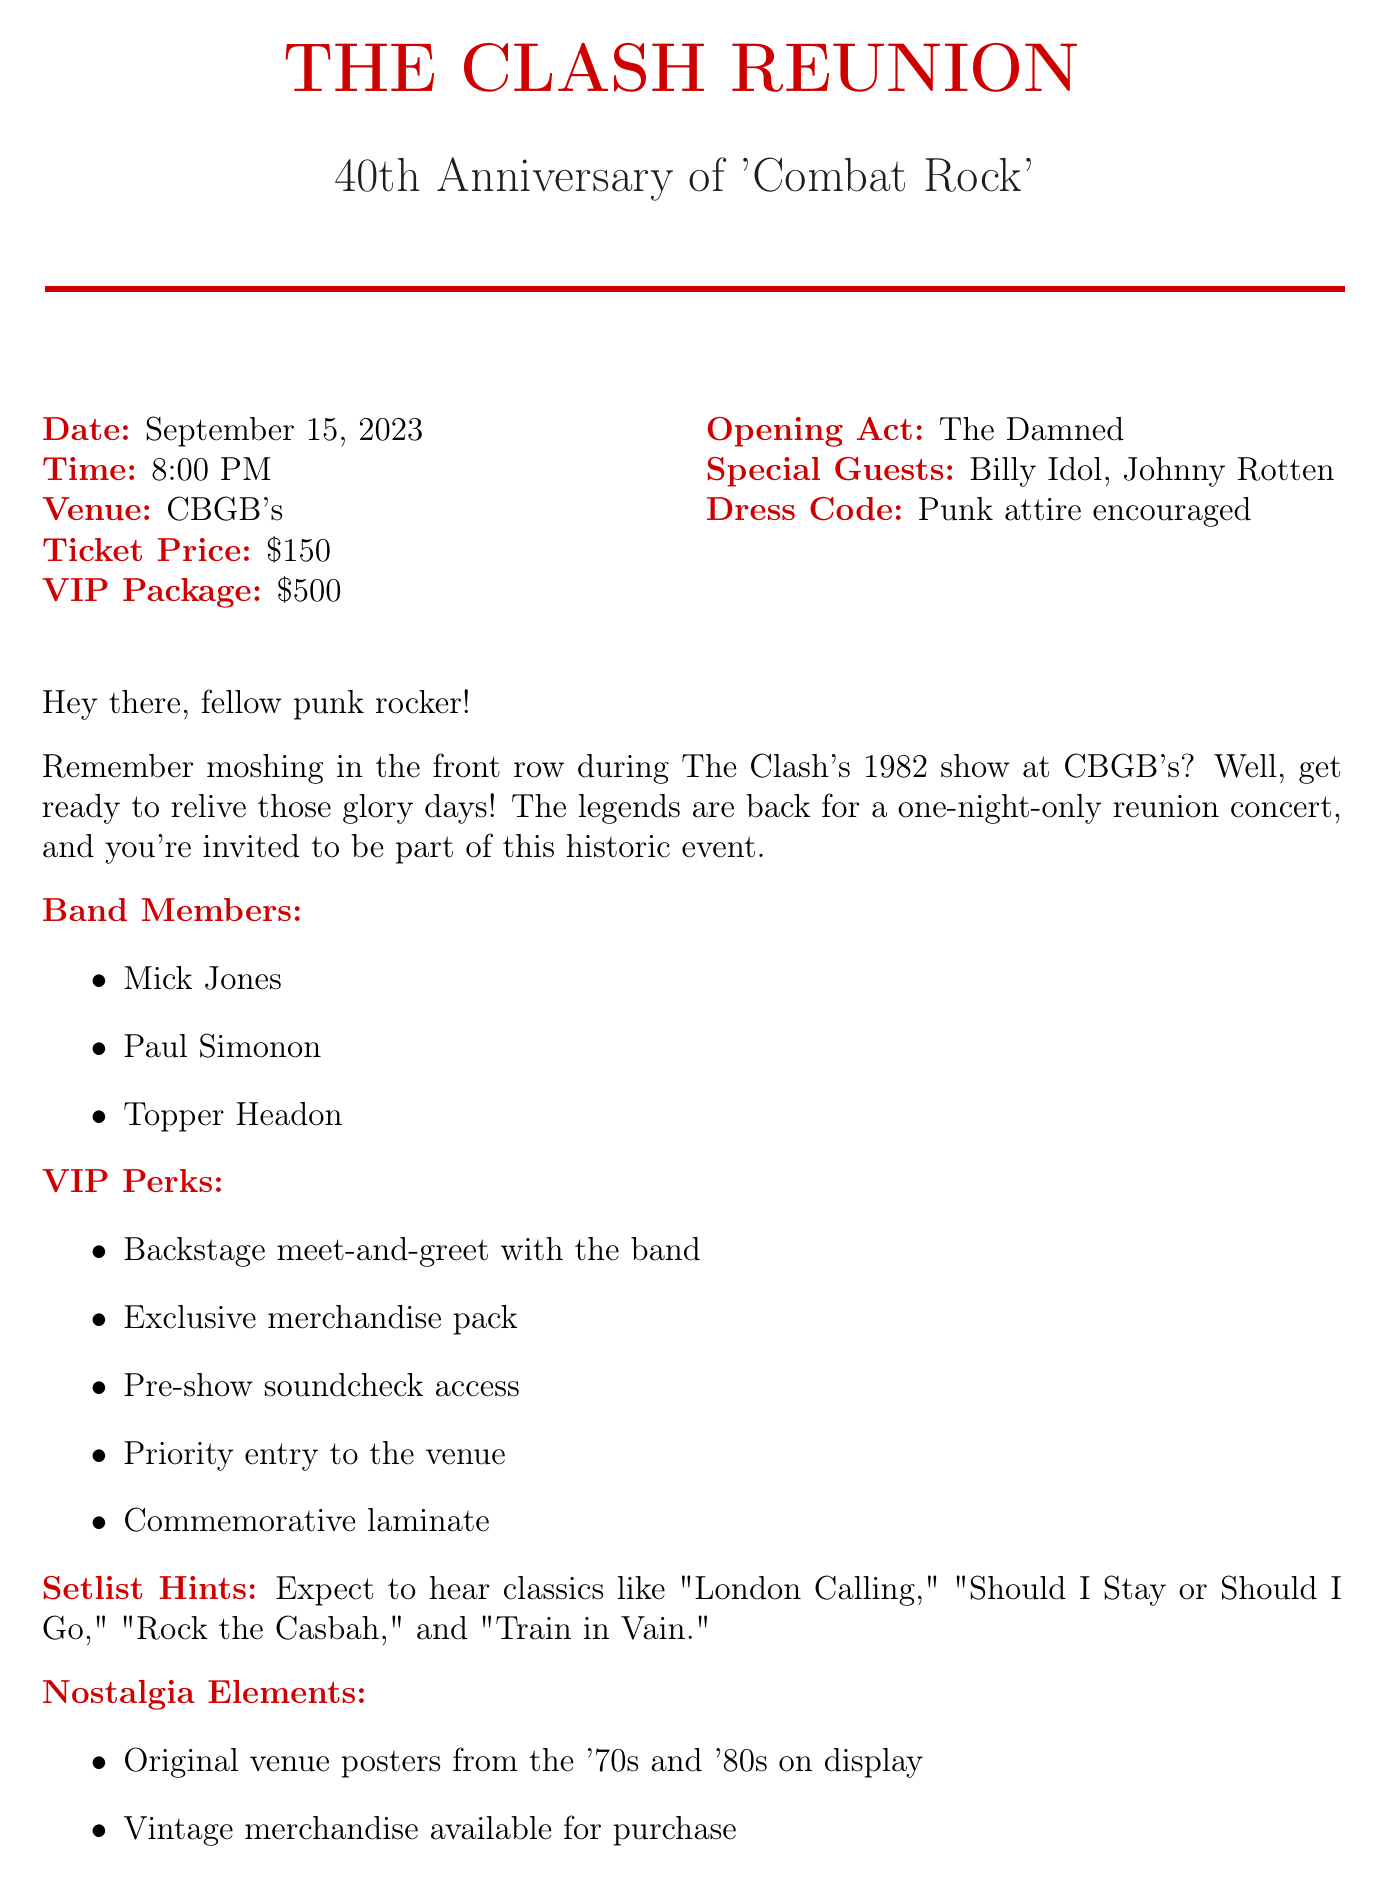What is the concert date? The concert date is explicitly mentioned in the document as September 15, 2023.
Answer: September 15, 2023 What is the ticket price? The ticket price is stated clearly in the document as $150.
Answer: $150 Who is the opening act? The opening act is listed in the document as The Damned.
Answer: The Damned What VIP perk includes meeting the band? The VIP perk that includes meeting the band is a backstage meet-and-greet.
Answer: Backstage meet-and-greet How many band members are listed? The number of band members can be counted from the list provided in the document, which includes three names.
Answer: Three What is the dress code for the concert? The dress code is explicitly mentioned in the document as punk attire encouraged.
Answer: Punk attire encouraged Which album's anniversary is being celebrated? The anniversary being celebrated is that of the 'Combat Rock' album, as noted in the document.
Answer: Combat Rock Which two special guests are mentioned? The document specifically names two special guests: Billy Idol and Johnny Rotten.
Answer: Billy Idol, Johnny Rotten What nostalgic element includes original posters? The nostalgic element that includes original posters refers to original venue posters from the '70s and '80s on display.
Answer: Original venue posters from the '70s and '80s on display 